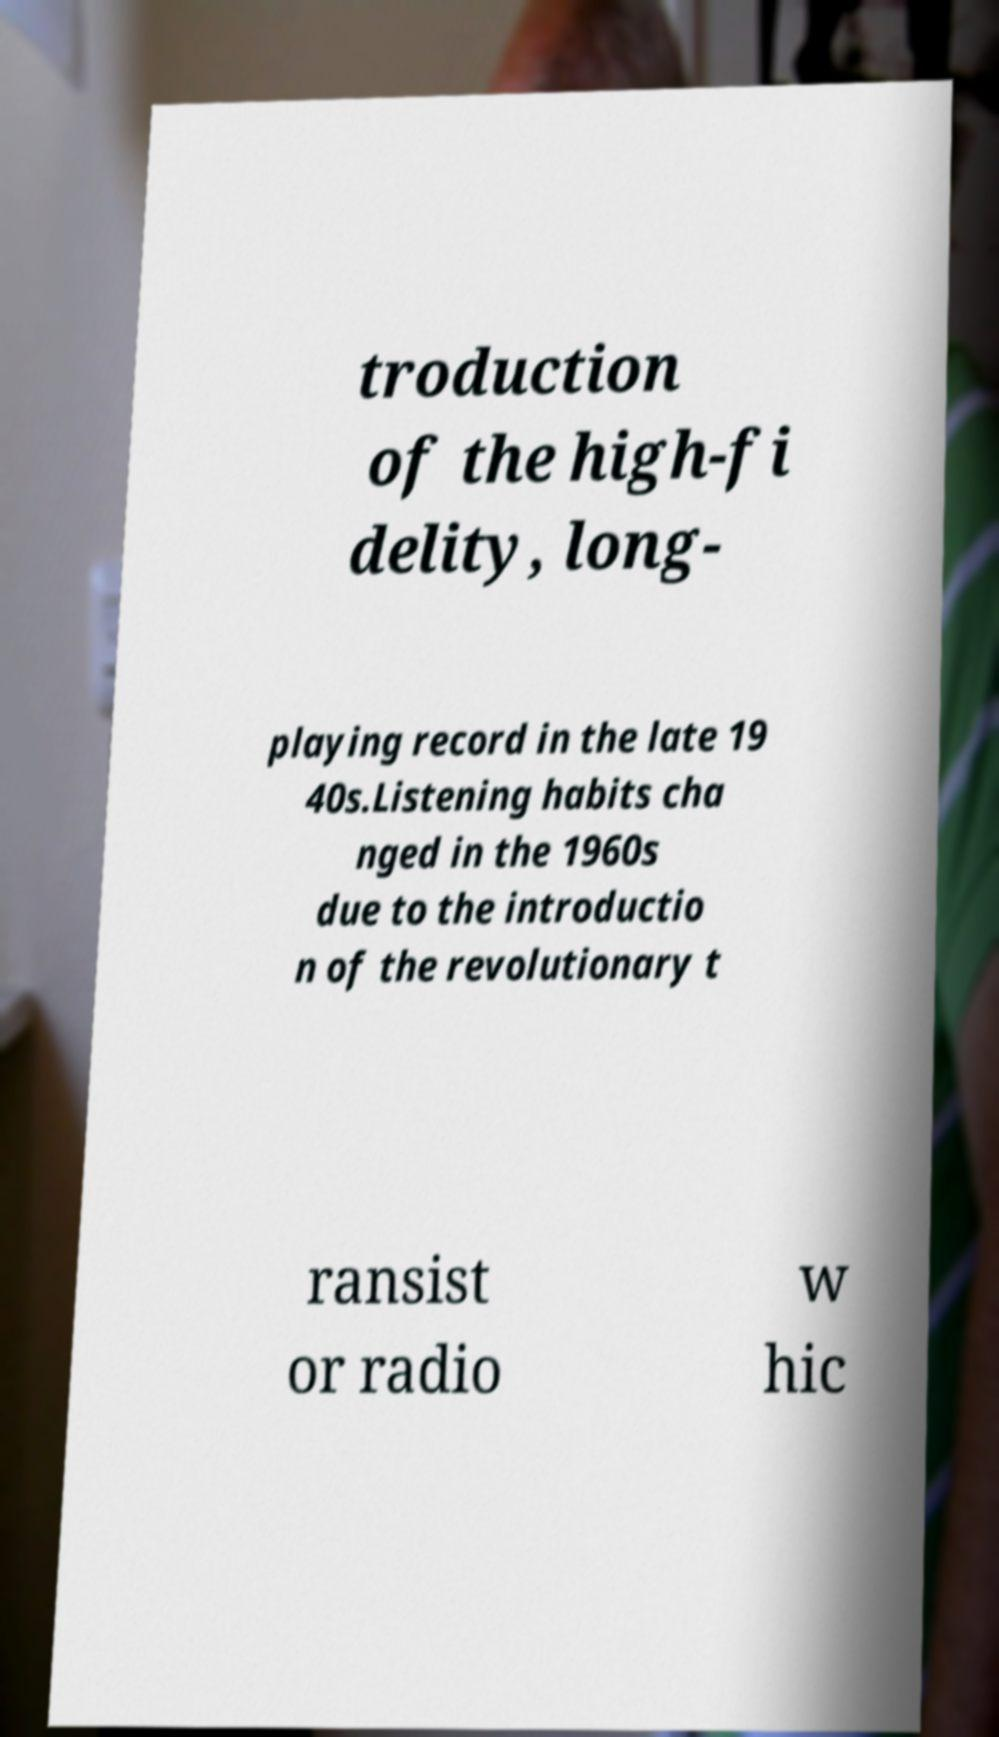Can you read and provide the text displayed in the image?This photo seems to have some interesting text. Can you extract and type it out for me? troduction of the high-fi delity, long- playing record in the late 19 40s.Listening habits cha nged in the 1960s due to the introductio n of the revolutionary t ransist or radio w hic 